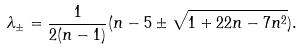<formula> <loc_0><loc_0><loc_500><loc_500>\lambda _ { \pm } = \frac { 1 } { 2 ( n - 1 ) } ( n - 5 \pm \sqrt { 1 + 2 2 n - 7 n ^ { 2 } } ) .</formula> 